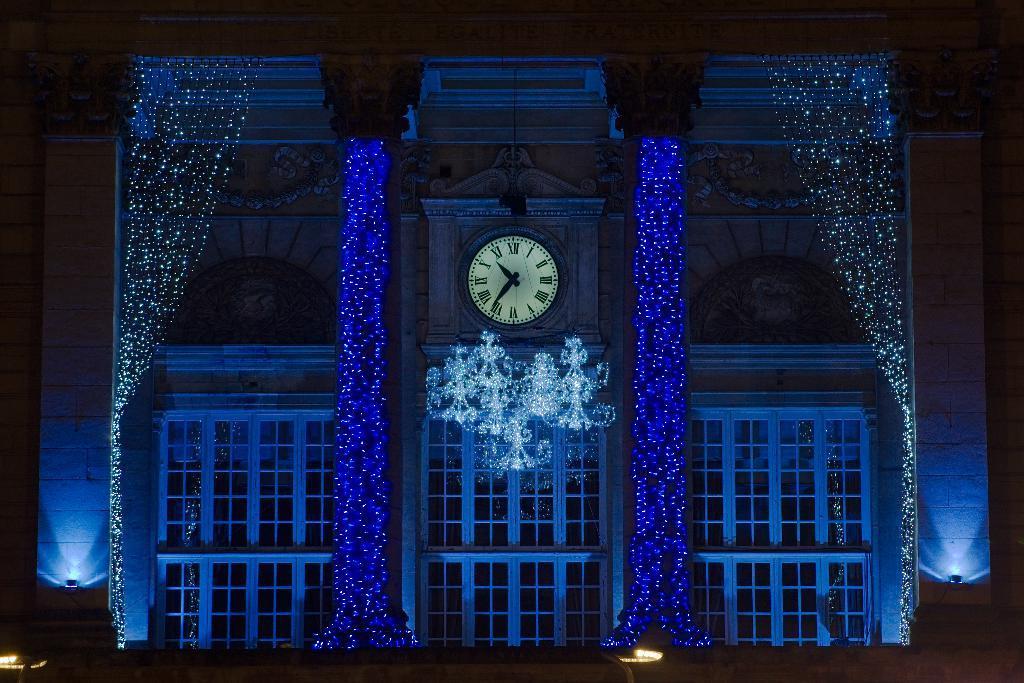Please provide a concise description of this image. In this image we can see a building with lights. There are windows. There is a clock on the wall. 